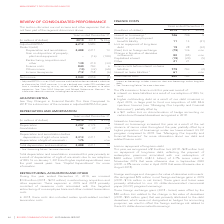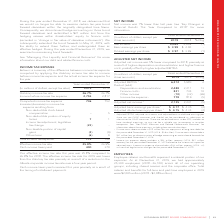According to Rogers Communications's financial document, What was the effective tax rate in 2019? According to the financial document, 25.8%. The relevant text states: "Effective income tax rate 25.8% 26.9% Cash income taxes paid 400 370..." Also, What was the effective tax rate in 2018? According to the financial document, 26.9%. The relevant text states: "Effective income tax rate 25.8% 26.9% Cash income taxes paid 400 370..." Also, What caused the decrease in effective tax rate from 2018 to 2019? reduction to the Alberta corporate income tax rate over a four-year period. The document states: "the statutory tax rate primarily as a result of a reduction to the Alberta corporate income tax rate over a four-year period...." Also, can you calculate: What was the increase / (decrease) in Adjusted EBITDA from 2018 to 2019? Based on the calculation: 6,212 - 5,983, the result is 229 (in millions). This is based on the information: "Adjusted EBITDA 1 6,212 5,983 4 Deduct (add): Depreciation and amortization 2,488 2,211 13 Gain on disposition of property, plant Adjusted EBITDA 1 6,212 5,983 4 Deduct (add): Depreciation and amortiz..." The key data points involved are: 5,983, 6,212. Also, can you calculate: What was the average Depreciation and amortization? To answer this question, I need to perform calculations using the financial data. The calculation is: (2,488 + 2,211) / 2, which equals 2349.5 (in millions). This is based on the information: "983 4 Deduct (add): Depreciation and amortization 2,488 2,211 13 Gain on disposition of property, plant and equipment – (16) (100) Restructuring, acquisiti Deduct (add): Depreciation and amortization ..." The key data points involved are: 2,211, 2,488. Also, can you calculate: What was the increase / (decrease) in Finance cost from 2018 to 2019? Based on the calculation: 840 - 793, the result is 47 (in millions). This is based on the information: "uisition and other 139 210 (34) Finance costs 840 793 6 Other income (10) (32) (69) Income tax expense 712 758 (6) acquisition and other 139 210 (34) Finance costs 840 793 6 Other income (10) (32) (69..." The key data points involved are: 793, 840. 